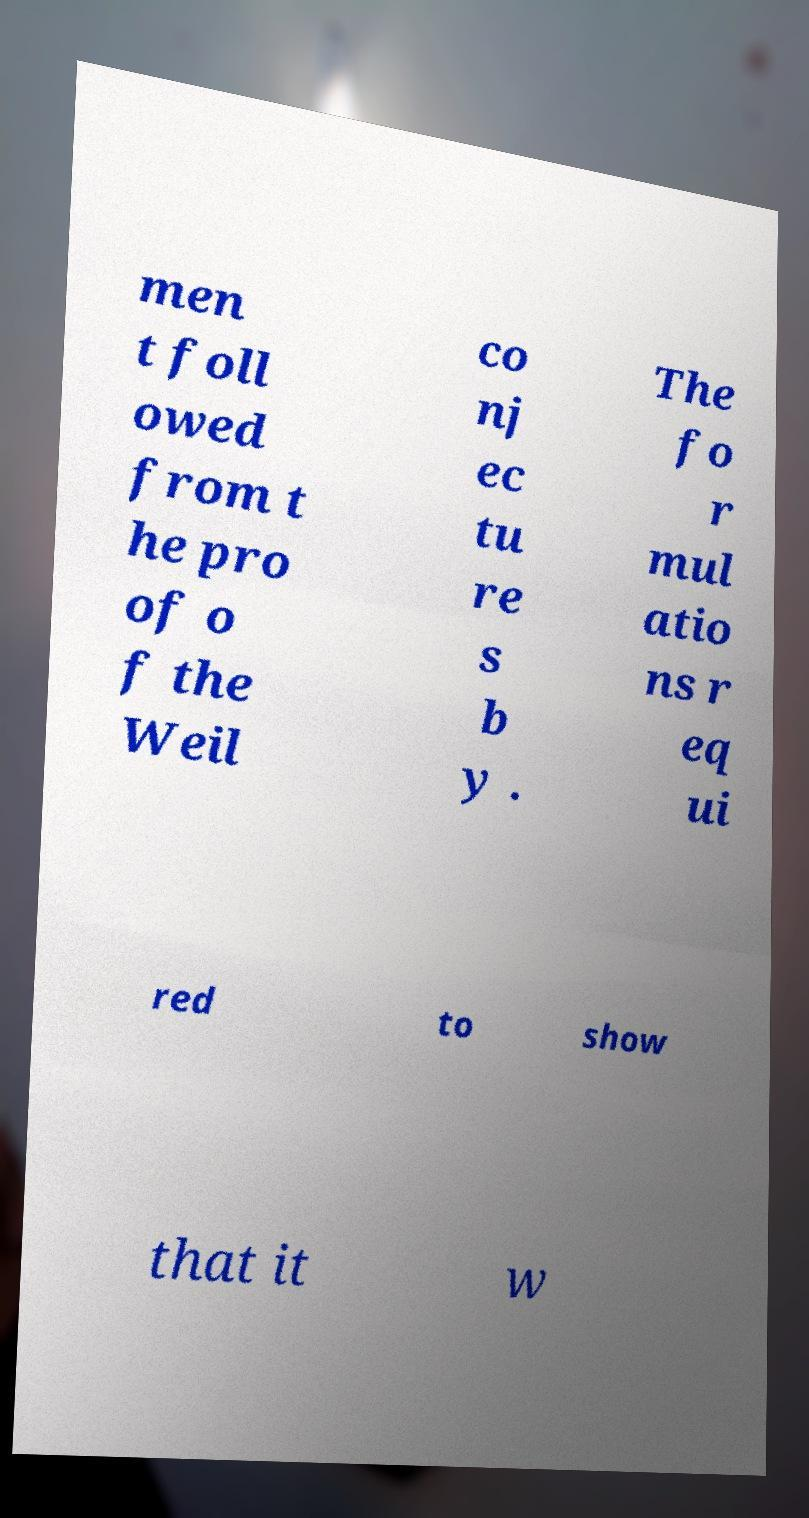What messages or text are displayed in this image? I need them in a readable, typed format. men t foll owed from t he pro of o f the Weil co nj ec tu re s b y . The fo r mul atio ns r eq ui red to show that it w 